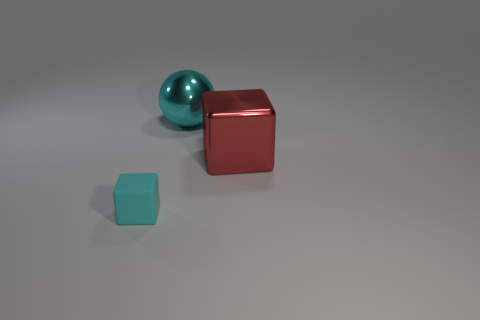Subtract all red cubes. How many cubes are left? 1 Subtract all spheres. How many objects are left? 2 Subtract 1 balls. How many balls are left? 0 Subtract all gray cylinders. How many blue spheres are left? 0 Subtract all blue rubber objects. Subtract all small rubber blocks. How many objects are left? 2 Add 2 large cyan balls. How many large cyan balls are left? 3 Add 3 red metallic objects. How many red metallic objects exist? 4 Add 2 small brown shiny cylinders. How many objects exist? 5 Subtract 1 red cubes. How many objects are left? 2 Subtract all red spheres. Subtract all red cylinders. How many spheres are left? 1 